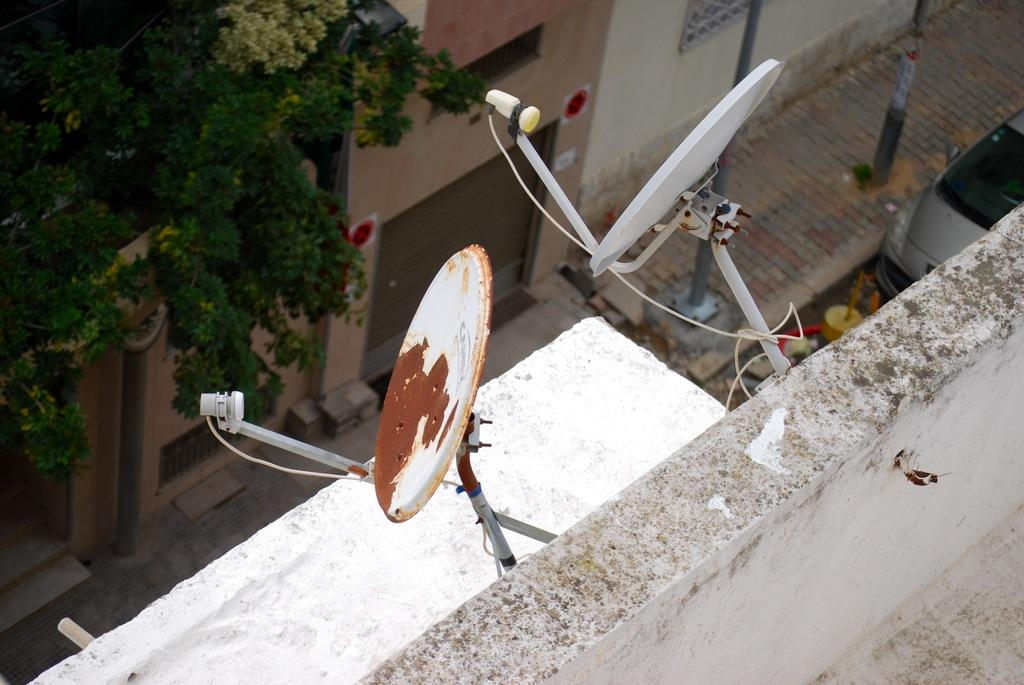What is attached to the wall in the image? There are two dishes attached to the wall in the image. What color is the wall? The wall is white. What can be seen in the background of the image? Buildings, windows, and trees are visible in the background of the image. What other objects are present in the image? There are poles in the image. Is there any transportation visible in the image? Yes, a vehicle is present on the road in the image. What type of sign is hanging on the wall next to the dishes? There is no sign present on the wall next to the dishes in the image. What material is the canvas made of that the buildings are painted on? There is no canvas present in the image; the buildings are real structures visible in the background. 